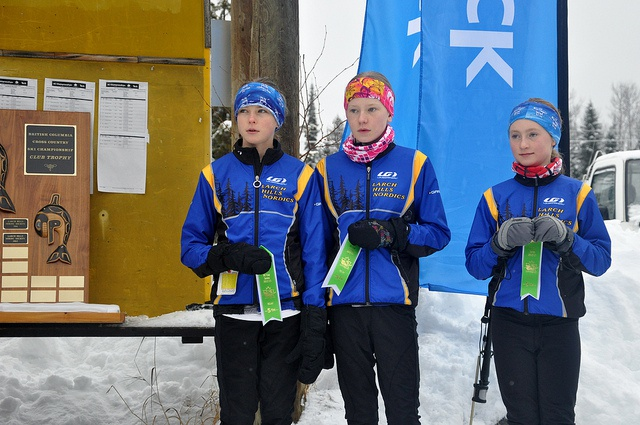Describe the objects in this image and their specific colors. I can see people in olive, black, darkblue, blue, and navy tones, people in olive, black, darkblue, blue, and navy tones, and people in olive, black, blue, darkblue, and navy tones in this image. 